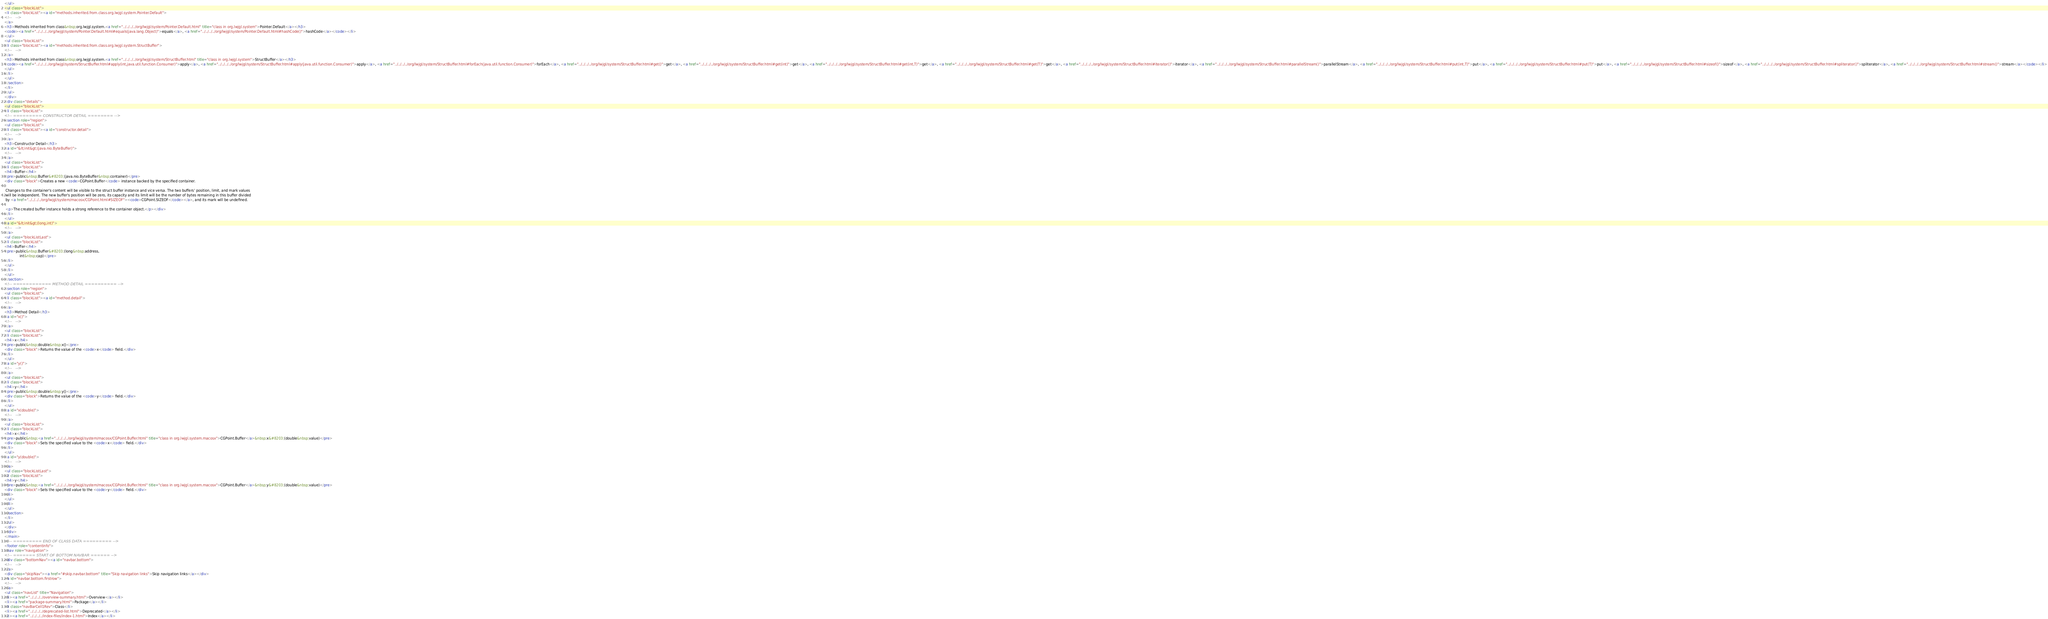Convert code to text. <code><loc_0><loc_0><loc_500><loc_500><_HTML_></ul>
<ul class="blockList">
<li class="blockList"><a id="methods.inherited.from.class.org.lwjgl.system.Pointer.Default">
<!--   -->
</a>
<h3>Methods inherited from class&nbsp;org.lwjgl.system.<a href="../../../../org/lwjgl/system/Pointer.Default.html" title="class in org.lwjgl.system">Pointer.Default</a></h3>
<code><a href="../../../../org/lwjgl/system/Pointer.Default.html#equals(java.lang.Object)">equals</a>, <a href="../../../../org/lwjgl/system/Pointer.Default.html#hashCode()">hashCode</a></code></li>
</ul>
<ul class="blockList">
<li class="blockList"><a id="methods.inherited.from.class.org.lwjgl.system.StructBuffer">
<!--   -->
</a>
<h3>Methods inherited from class&nbsp;org.lwjgl.system.<a href="../../../../org/lwjgl/system/StructBuffer.html" title="class in org.lwjgl.system">StructBuffer</a></h3>
<code><a href="../../../../org/lwjgl/system/StructBuffer.html#apply(int,java.util.function.Consumer)">apply</a>, <a href="../../../../org/lwjgl/system/StructBuffer.html#apply(java.util.function.Consumer)">apply</a>, <a href="../../../../org/lwjgl/system/StructBuffer.html#forEach(java.util.function.Consumer)">forEach</a>, <a href="../../../../org/lwjgl/system/StructBuffer.html#get()">get</a>, <a href="../../../../org/lwjgl/system/StructBuffer.html#get(int)">get</a>, <a href="../../../../org/lwjgl/system/StructBuffer.html#get(int,T)">get</a>, <a href="../../../../org/lwjgl/system/StructBuffer.html#get(T)">get</a>, <a href="../../../../org/lwjgl/system/StructBuffer.html#iterator()">iterator</a>, <a href="../../../../org/lwjgl/system/StructBuffer.html#parallelStream()">parallelStream</a>, <a href="../../../../org/lwjgl/system/StructBuffer.html#put(int,T)">put</a>, <a href="../../../../org/lwjgl/system/StructBuffer.html#put(T)">put</a>, <a href="../../../../org/lwjgl/system/StructBuffer.html#sizeof()">sizeof</a>, <a href="../../../../org/lwjgl/system/StructBuffer.html#spliterator()">spliterator</a>, <a href="../../../../org/lwjgl/system/StructBuffer.html#stream()">stream</a></code></li>
</ul>
</li>
</ul>
</section>
</li>
</ul>
</div>
<div class="details">
<ul class="blockList">
<li class="blockList">
<!-- ========= CONSTRUCTOR DETAIL ======== -->
<section role="region">
<ul class="blockList">
<li class="blockList"><a id="constructor.detail">
<!--   -->
</a>
<h3>Constructor Detail</h3>
<a id="&lt;init&gt;(java.nio.ByteBuffer)">
<!--   -->
</a>
<ul class="blockList">
<li class="blockList">
<h4>Buffer</h4>
<pre>public&nbsp;Buffer&#8203;(java.nio.ByteBuffer&nbsp;container)</pre>
<div class="block">Creates a new <code>CGPoint.Buffer</code> instance backed by the specified container.

 Changes to the container's content will be visible to the struct buffer instance and vice versa. The two buffers' position, limit, and mark values
 will be independent. The new buffer's position will be zero, its capacity and its limit will be the number of bytes remaining in this buffer divided
 by <a href="../../../../org/lwjgl/system/macosx/CGPoint.html#SIZEOF"><code>CGPoint.SIZEOF</code></a>, and its mark will be undefined.

 <p>The created buffer instance holds a strong reference to the container object.</p></div>
</li>
</ul>
<a id="&lt;init&gt;(long,int)">
<!--   -->
</a>
<ul class="blockListLast">
<li class="blockList">
<h4>Buffer</h4>
<pre>public&nbsp;Buffer&#8203;(long&nbsp;address,
              int&nbsp;cap)</pre>
</li>
</ul>
</li>
</ul>
</section>
<!-- ============ METHOD DETAIL ========== -->
<section role="region">
<ul class="blockList">
<li class="blockList"><a id="method.detail">
<!--   -->
</a>
<h3>Method Detail</h3>
<a id="x()">
<!--   -->
</a>
<ul class="blockList">
<li class="blockList">
<h4>x</h4>
<pre>public&nbsp;double&nbsp;x()</pre>
<div class="block">Returns the value of the <code>x</code> field.</div>
</li>
</ul>
<a id="y()">
<!--   -->
</a>
<ul class="blockList">
<li class="blockList">
<h4>y</h4>
<pre>public&nbsp;double&nbsp;y()</pre>
<div class="block">Returns the value of the <code>y</code> field.</div>
</li>
</ul>
<a id="x(double)">
<!--   -->
</a>
<ul class="blockList">
<li class="blockList">
<h4>x</h4>
<pre>public&nbsp;<a href="../../../../org/lwjgl/system/macosx/CGPoint.Buffer.html" title="class in org.lwjgl.system.macosx">CGPoint.Buffer</a>&nbsp;x&#8203;(double&nbsp;value)</pre>
<div class="block">Sets the specified value to the <code>x</code> field.</div>
</li>
</ul>
<a id="y(double)">
<!--   -->
</a>
<ul class="blockListLast">
<li class="blockList">
<h4>y</h4>
<pre>public&nbsp;<a href="../../../../org/lwjgl/system/macosx/CGPoint.Buffer.html" title="class in org.lwjgl.system.macosx">CGPoint.Buffer</a>&nbsp;y&#8203;(double&nbsp;value)</pre>
<div class="block">Sets the specified value to the <code>y</code> field.</div>
</li>
</ul>
</li>
</ul>
</section>
</li>
</ul>
</div>
</div>
</main>
<!-- ========= END OF CLASS DATA ========= -->
<footer role="contentinfo">
<nav role="navigation">
<!-- ======= START OF BOTTOM NAVBAR ====== -->
<div class="bottomNav"><a id="navbar.bottom">
<!--   -->
</a>
<div class="skipNav"><a href="#skip.navbar.bottom" title="Skip navigation links">Skip navigation links</a></div>
<a id="navbar.bottom.firstrow">
<!--   -->
</a>
<ul class="navList" title="Navigation">
<li><a href="../../../../overview-summary.html">Overview</a></li>
<li><a href="package-summary.html">Package</a></li>
<li class="navBarCell1Rev">Class</li>
<li><a href="../../../../deprecated-list.html">Deprecated</a></li>
<li><a href="../../../../index-files/index-1.html">Index</a></li></code> 